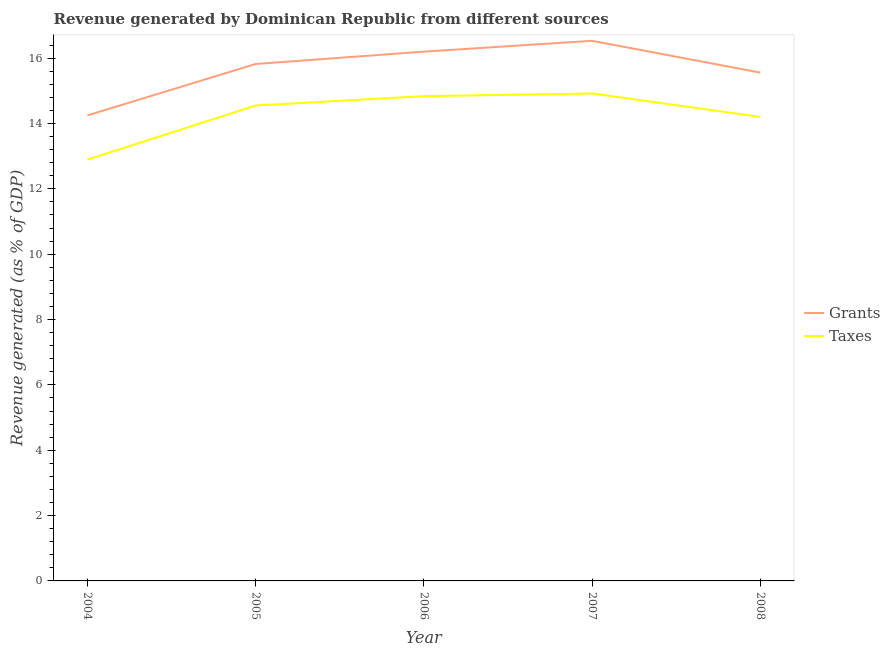Does the line corresponding to revenue generated by grants intersect with the line corresponding to revenue generated by taxes?
Ensure brevity in your answer.  No. Is the number of lines equal to the number of legend labels?
Give a very brief answer. Yes. What is the revenue generated by grants in 2007?
Your answer should be compact. 16.53. Across all years, what is the maximum revenue generated by grants?
Keep it short and to the point. 16.53. Across all years, what is the minimum revenue generated by taxes?
Offer a terse response. 12.89. In which year was the revenue generated by grants maximum?
Provide a short and direct response. 2007. In which year was the revenue generated by taxes minimum?
Make the answer very short. 2004. What is the total revenue generated by taxes in the graph?
Give a very brief answer. 71.4. What is the difference between the revenue generated by grants in 2006 and that in 2007?
Your response must be concise. -0.33. What is the difference between the revenue generated by grants in 2007 and the revenue generated by taxes in 2008?
Your response must be concise. 2.33. What is the average revenue generated by taxes per year?
Keep it short and to the point. 14.28. In the year 2008, what is the difference between the revenue generated by grants and revenue generated by taxes?
Offer a terse response. 1.36. What is the ratio of the revenue generated by taxes in 2005 to that in 2006?
Keep it short and to the point. 0.98. Is the revenue generated by taxes in 2004 less than that in 2005?
Provide a succinct answer. Yes. What is the difference between the highest and the second highest revenue generated by taxes?
Your response must be concise. 0.08. What is the difference between the highest and the lowest revenue generated by grants?
Ensure brevity in your answer.  2.28. In how many years, is the revenue generated by taxes greater than the average revenue generated by taxes taken over all years?
Your answer should be compact. 3. Does the revenue generated by grants monotonically increase over the years?
Make the answer very short. No. Is the revenue generated by grants strictly greater than the revenue generated by taxes over the years?
Make the answer very short. Yes. Is the revenue generated by grants strictly less than the revenue generated by taxes over the years?
Make the answer very short. No. How many years are there in the graph?
Provide a succinct answer. 5. Does the graph contain any zero values?
Give a very brief answer. No. Does the graph contain grids?
Keep it short and to the point. No. Where does the legend appear in the graph?
Make the answer very short. Center right. What is the title of the graph?
Offer a very short reply. Revenue generated by Dominican Republic from different sources. What is the label or title of the Y-axis?
Give a very brief answer. Revenue generated (as % of GDP). What is the Revenue generated (as % of GDP) of Grants in 2004?
Keep it short and to the point. 14.25. What is the Revenue generated (as % of GDP) of Taxes in 2004?
Provide a succinct answer. 12.89. What is the Revenue generated (as % of GDP) in Grants in 2005?
Your answer should be compact. 15.82. What is the Revenue generated (as % of GDP) of Taxes in 2005?
Provide a succinct answer. 14.55. What is the Revenue generated (as % of GDP) of Grants in 2006?
Your answer should be very brief. 16.2. What is the Revenue generated (as % of GDP) of Taxes in 2006?
Provide a short and direct response. 14.84. What is the Revenue generated (as % of GDP) in Grants in 2007?
Provide a short and direct response. 16.53. What is the Revenue generated (as % of GDP) of Taxes in 2007?
Offer a very short reply. 14.92. What is the Revenue generated (as % of GDP) in Grants in 2008?
Provide a succinct answer. 15.56. What is the Revenue generated (as % of GDP) in Taxes in 2008?
Ensure brevity in your answer.  14.2. Across all years, what is the maximum Revenue generated (as % of GDP) in Grants?
Make the answer very short. 16.53. Across all years, what is the maximum Revenue generated (as % of GDP) of Taxes?
Your response must be concise. 14.92. Across all years, what is the minimum Revenue generated (as % of GDP) of Grants?
Keep it short and to the point. 14.25. Across all years, what is the minimum Revenue generated (as % of GDP) in Taxes?
Give a very brief answer. 12.89. What is the total Revenue generated (as % of GDP) of Grants in the graph?
Give a very brief answer. 78.35. What is the total Revenue generated (as % of GDP) of Taxes in the graph?
Your response must be concise. 71.4. What is the difference between the Revenue generated (as % of GDP) of Grants in 2004 and that in 2005?
Provide a short and direct response. -1.57. What is the difference between the Revenue generated (as % of GDP) in Taxes in 2004 and that in 2005?
Provide a succinct answer. -1.66. What is the difference between the Revenue generated (as % of GDP) of Grants in 2004 and that in 2006?
Offer a very short reply. -1.95. What is the difference between the Revenue generated (as % of GDP) in Taxes in 2004 and that in 2006?
Offer a very short reply. -1.94. What is the difference between the Revenue generated (as % of GDP) of Grants in 2004 and that in 2007?
Give a very brief answer. -2.28. What is the difference between the Revenue generated (as % of GDP) in Taxes in 2004 and that in 2007?
Keep it short and to the point. -2.03. What is the difference between the Revenue generated (as % of GDP) in Grants in 2004 and that in 2008?
Provide a succinct answer. -1.31. What is the difference between the Revenue generated (as % of GDP) in Taxes in 2004 and that in 2008?
Give a very brief answer. -1.31. What is the difference between the Revenue generated (as % of GDP) in Grants in 2005 and that in 2006?
Keep it short and to the point. -0.38. What is the difference between the Revenue generated (as % of GDP) in Taxes in 2005 and that in 2006?
Provide a succinct answer. -0.29. What is the difference between the Revenue generated (as % of GDP) in Grants in 2005 and that in 2007?
Your response must be concise. -0.71. What is the difference between the Revenue generated (as % of GDP) of Taxes in 2005 and that in 2007?
Keep it short and to the point. -0.37. What is the difference between the Revenue generated (as % of GDP) in Grants in 2005 and that in 2008?
Your response must be concise. 0.26. What is the difference between the Revenue generated (as % of GDP) of Taxes in 2005 and that in 2008?
Offer a very short reply. 0.35. What is the difference between the Revenue generated (as % of GDP) of Grants in 2006 and that in 2007?
Ensure brevity in your answer.  -0.33. What is the difference between the Revenue generated (as % of GDP) in Taxes in 2006 and that in 2007?
Keep it short and to the point. -0.08. What is the difference between the Revenue generated (as % of GDP) of Grants in 2006 and that in 2008?
Provide a short and direct response. 0.64. What is the difference between the Revenue generated (as % of GDP) in Taxes in 2006 and that in 2008?
Give a very brief answer. 0.64. What is the difference between the Revenue generated (as % of GDP) of Grants in 2007 and that in 2008?
Your response must be concise. 0.97. What is the difference between the Revenue generated (as % of GDP) of Taxes in 2007 and that in 2008?
Your answer should be compact. 0.72. What is the difference between the Revenue generated (as % of GDP) in Grants in 2004 and the Revenue generated (as % of GDP) in Taxes in 2005?
Make the answer very short. -0.3. What is the difference between the Revenue generated (as % of GDP) in Grants in 2004 and the Revenue generated (as % of GDP) in Taxes in 2006?
Make the answer very short. -0.59. What is the difference between the Revenue generated (as % of GDP) of Grants in 2004 and the Revenue generated (as % of GDP) of Taxes in 2007?
Offer a terse response. -0.67. What is the difference between the Revenue generated (as % of GDP) in Grants in 2004 and the Revenue generated (as % of GDP) in Taxes in 2008?
Make the answer very short. 0.05. What is the difference between the Revenue generated (as % of GDP) of Grants in 2005 and the Revenue generated (as % of GDP) of Taxes in 2006?
Offer a terse response. 0.98. What is the difference between the Revenue generated (as % of GDP) in Grants in 2005 and the Revenue generated (as % of GDP) in Taxes in 2007?
Offer a terse response. 0.9. What is the difference between the Revenue generated (as % of GDP) of Grants in 2005 and the Revenue generated (as % of GDP) of Taxes in 2008?
Your answer should be compact. 1.62. What is the difference between the Revenue generated (as % of GDP) of Grants in 2006 and the Revenue generated (as % of GDP) of Taxes in 2007?
Offer a very short reply. 1.28. What is the difference between the Revenue generated (as % of GDP) in Grants in 2006 and the Revenue generated (as % of GDP) in Taxes in 2008?
Provide a short and direct response. 2. What is the difference between the Revenue generated (as % of GDP) in Grants in 2007 and the Revenue generated (as % of GDP) in Taxes in 2008?
Your answer should be compact. 2.33. What is the average Revenue generated (as % of GDP) of Grants per year?
Your answer should be compact. 15.67. What is the average Revenue generated (as % of GDP) of Taxes per year?
Give a very brief answer. 14.28. In the year 2004, what is the difference between the Revenue generated (as % of GDP) in Grants and Revenue generated (as % of GDP) in Taxes?
Keep it short and to the point. 1.35. In the year 2005, what is the difference between the Revenue generated (as % of GDP) in Grants and Revenue generated (as % of GDP) in Taxes?
Ensure brevity in your answer.  1.27. In the year 2006, what is the difference between the Revenue generated (as % of GDP) of Grants and Revenue generated (as % of GDP) of Taxes?
Offer a terse response. 1.36. In the year 2007, what is the difference between the Revenue generated (as % of GDP) in Grants and Revenue generated (as % of GDP) in Taxes?
Offer a very short reply. 1.61. In the year 2008, what is the difference between the Revenue generated (as % of GDP) in Grants and Revenue generated (as % of GDP) in Taxes?
Your answer should be very brief. 1.36. What is the ratio of the Revenue generated (as % of GDP) of Grants in 2004 to that in 2005?
Offer a terse response. 0.9. What is the ratio of the Revenue generated (as % of GDP) in Taxes in 2004 to that in 2005?
Give a very brief answer. 0.89. What is the ratio of the Revenue generated (as % of GDP) in Grants in 2004 to that in 2006?
Offer a very short reply. 0.88. What is the ratio of the Revenue generated (as % of GDP) in Taxes in 2004 to that in 2006?
Provide a succinct answer. 0.87. What is the ratio of the Revenue generated (as % of GDP) of Grants in 2004 to that in 2007?
Offer a terse response. 0.86. What is the ratio of the Revenue generated (as % of GDP) of Taxes in 2004 to that in 2007?
Keep it short and to the point. 0.86. What is the ratio of the Revenue generated (as % of GDP) of Grants in 2004 to that in 2008?
Provide a succinct answer. 0.92. What is the ratio of the Revenue generated (as % of GDP) in Taxes in 2004 to that in 2008?
Offer a very short reply. 0.91. What is the ratio of the Revenue generated (as % of GDP) in Grants in 2005 to that in 2006?
Your response must be concise. 0.98. What is the ratio of the Revenue generated (as % of GDP) of Taxes in 2005 to that in 2006?
Keep it short and to the point. 0.98. What is the ratio of the Revenue generated (as % of GDP) of Grants in 2005 to that in 2007?
Make the answer very short. 0.96. What is the ratio of the Revenue generated (as % of GDP) of Taxes in 2005 to that in 2007?
Your answer should be compact. 0.98. What is the ratio of the Revenue generated (as % of GDP) of Taxes in 2005 to that in 2008?
Provide a succinct answer. 1.02. What is the ratio of the Revenue generated (as % of GDP) of Taxes in 2006 to that in 2007?
Provide a short and direct response. 0.99. What is the ratio of the Revenue generated (as % of GDP) of Grants in 2006 to that in 2008?
Provide a succinct answer. 1.04. What is the ratio of the Revenue generated (as % of GDP) of Taxes in 2006 to that in 2008?
Keep it short and to the point. 1.04. What is the ratio of the Revenue generated (as % of GDP) in Grants in 2007 to that in 2008?
Offer a very short reply. 1.06. What is the ratio of the Revenue generated (as % of GDP) of Taxes in 2007 to that in 2008?
Offer a terse response. 1.05. What is the difference between the highest and the second highest Revenue generated (as % of GDP) in Grants?
Keep it short and to the point. 0.33. What is the difference between the highest and the second highest Revenue generated (as % of GDP) in Taxes?
Your response must be concise. 0.08. What is the difference between the highest and the lowest Revenue generated (as % of GDP) of Grants?
Your answer should be compact. 2.28. What is the difference between the highest and the lowest Revenue generated (as % of GDP) of Taxes?
Provide a succinct answer. 2.03. 